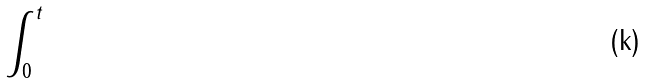Convert formula to latex. <formula><loc_0><loc_0><loc_500><loc_500>\int _ { 0 } ^ { t }</formula> 